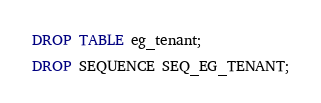<code> <loc_0><loc_0><loc_500><loc_500><_SQL_>DROP TABLE eg_tenant;

DROP SEQUENCE SEQ_EG_TENANT;</code> 